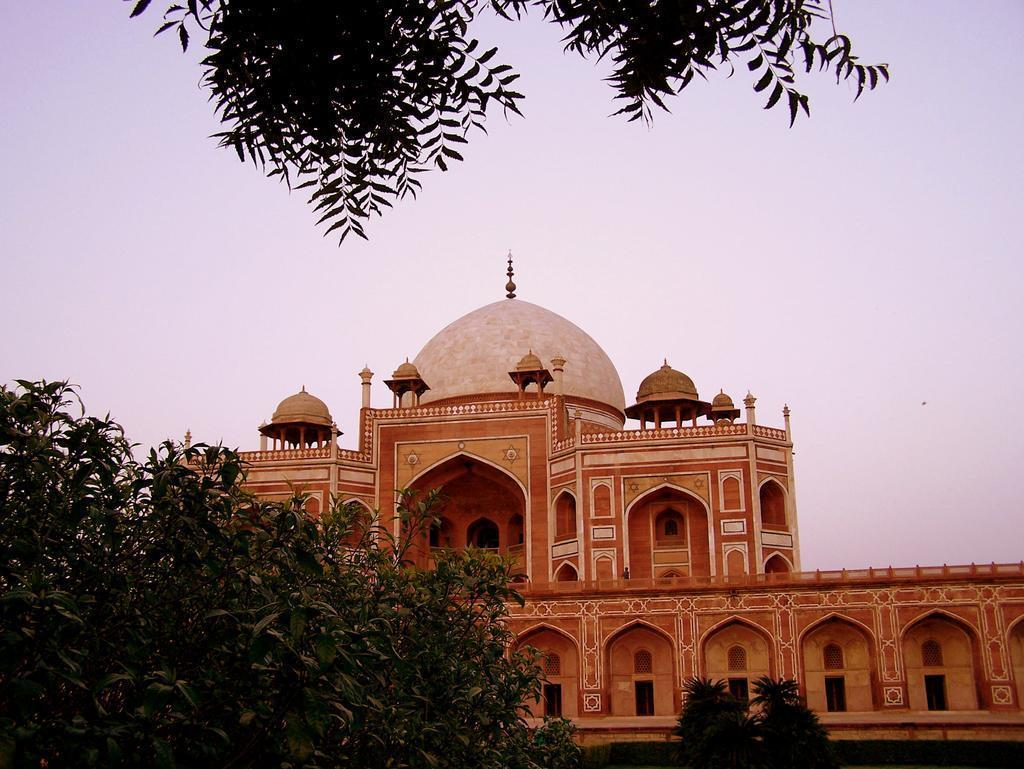What is the main structure in the center of the image? There is a red fort in the center of the image. What type of vegetation can be seen at the top of the image? There are plants at the top of the image. What type of vegetation can be seen at the bottom of the image? There are plants at the bottom of the image. What type of tin can be seen in the image? There is no tin present in the image. What part of the brain is visible in the image? There is no brain present in the image. 